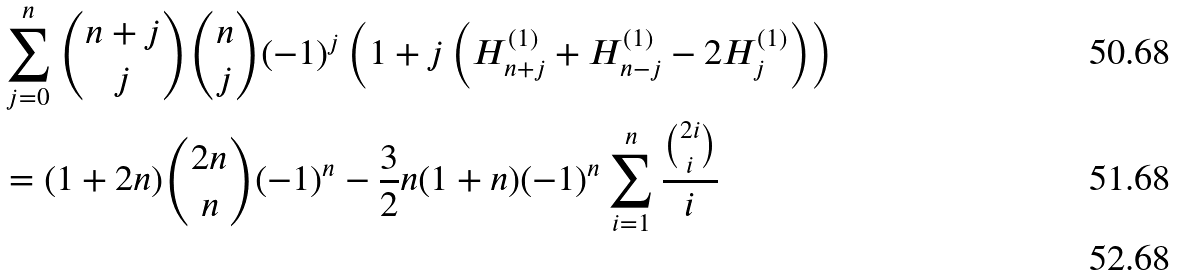Convert formula to latex. <formula><loc_0><loc_0><loc_500><loc_500>& \sum _ { j = 0 } ^ { n } \binom { n + j } { j } \binom { n } { j } ( - 1 ) ^ { j } \left ( 1 + j \left ( H _ { n + j } ^ { ( 1 ) } + H _ { n - j } ^ { ( 1 ) } - 2 H _ { j } ^ { ( 1 ) } \right ) \right ) \\ & = ( 1 + 2 n ) \binom { 2 n } { n } ( - 1 ) ^ { n } - \frac { 3 } { 2 } n ( 1 + n ) ( - 1 ) ^ { n } \sum _ { i = 1 } ^ { n } \frac { \binom { 2 i } { i } } { i } \\</formula> 